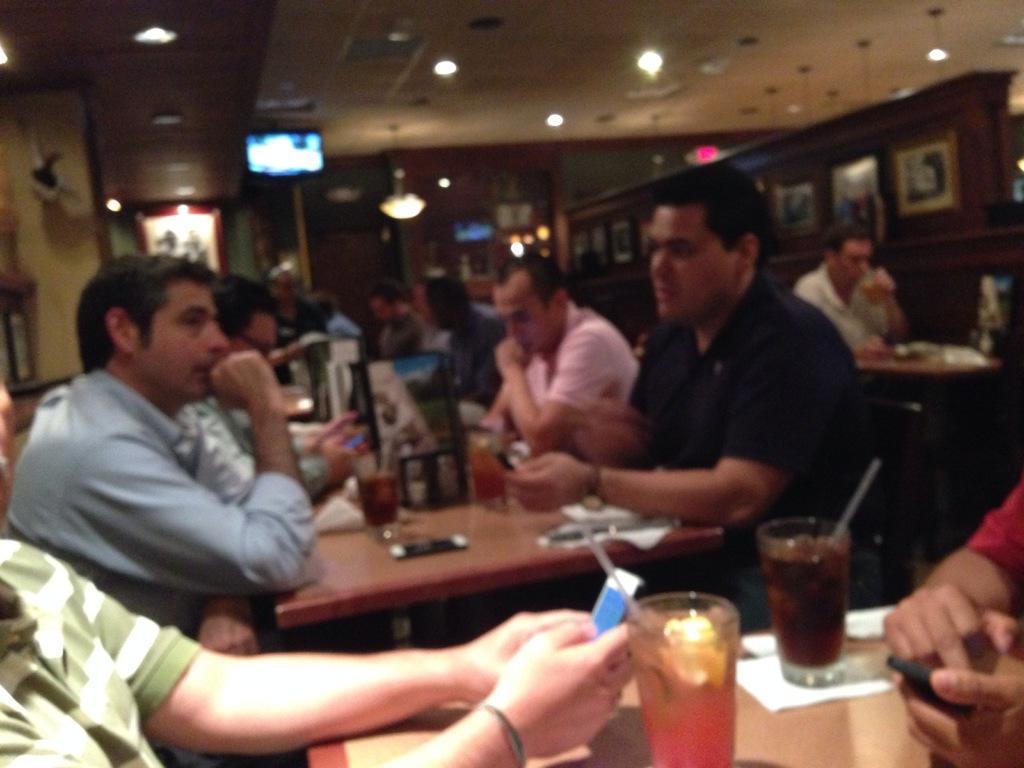Can you describe this image briefly? In the image we can see there are people who are sitting on the chair and in front of them there is a table on which there are glasses filled with cool drinks and on the other side the image is blur. 